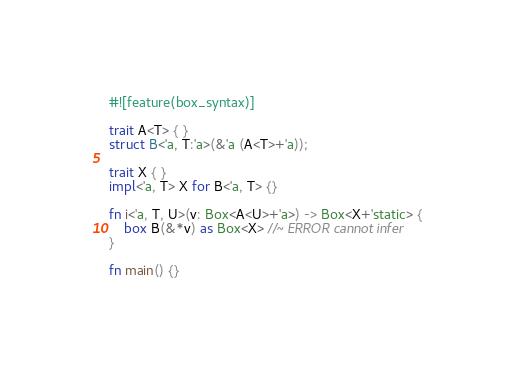Convert code to text. <code><loc_0><loc_0><loc_500><loc_500><_Rust_>#![feature(box_syntax)]

trait A<T> { }
struct B<'a, T:'a>(&'a (A<T>+'a));

trait X { }
impl<'a, T> X for B<'a, T> {}

fn i<'a, T, U>(v: Box<A<U>+'a>) -> Box<X+'static> {
    box B(&*v) as Box<X> //~ ERROR cannot infer
}

fn main() {}
</code> 